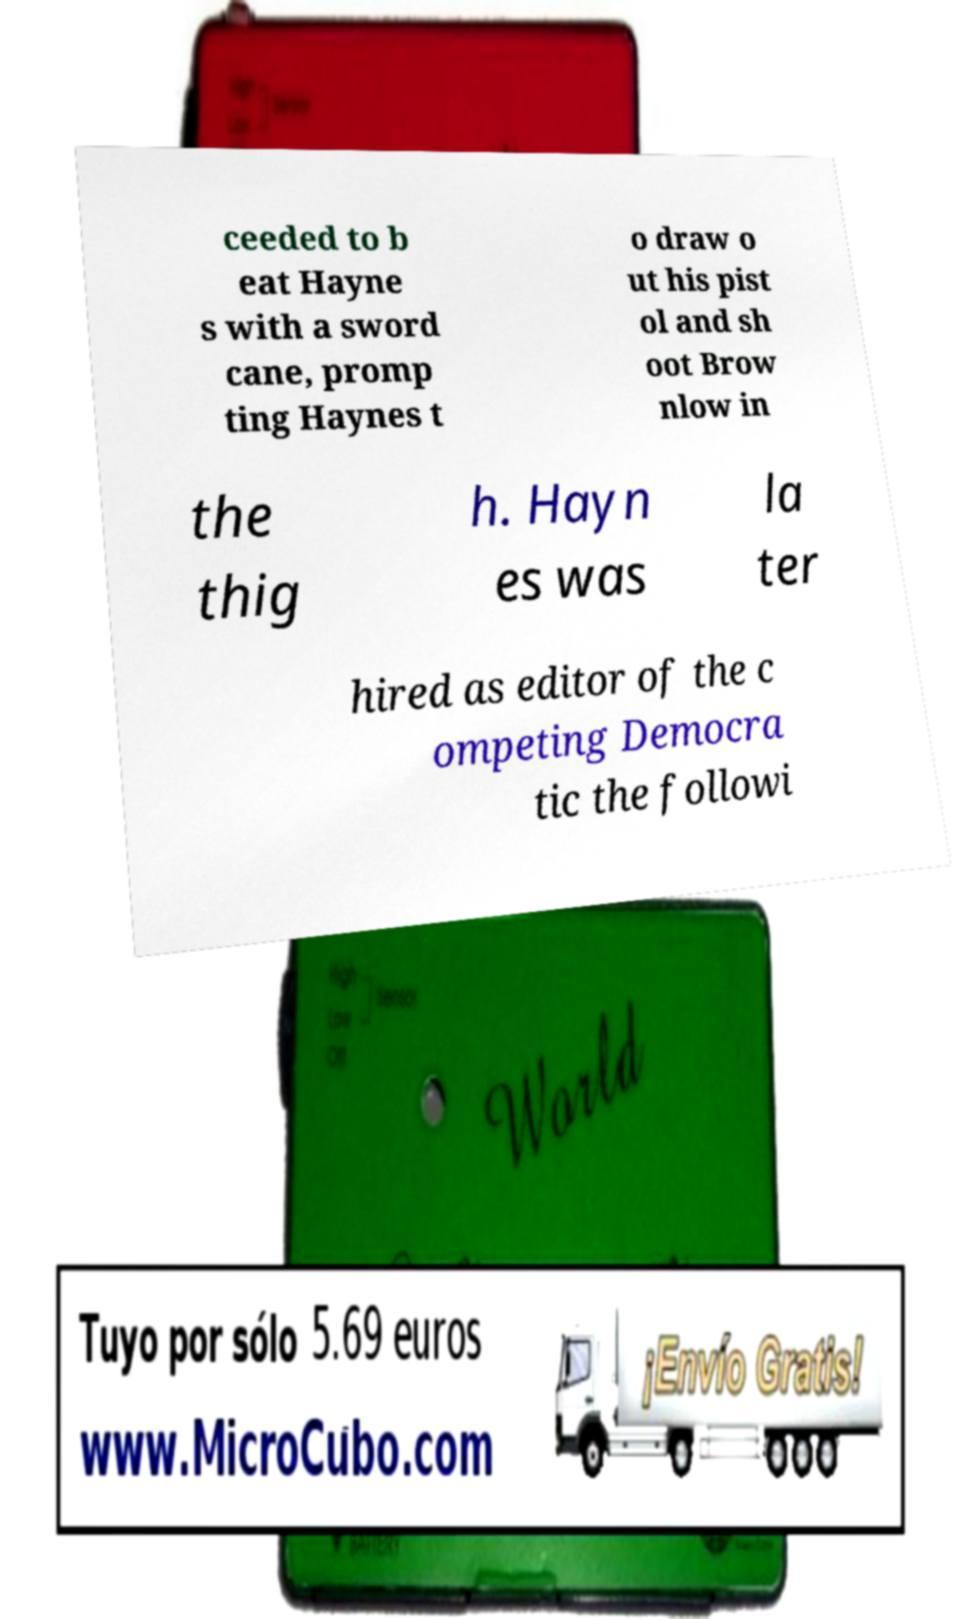Please read and relay the text visible in this image. What does it say? ceeded to b eat Hayne s with a sword cane, promp ting Haynes t o draw o ut his pist ol and sh oot Brow nlow in the thig h. Hayn es was la ter hired as editor of the c ompeting Democra tic the followi 